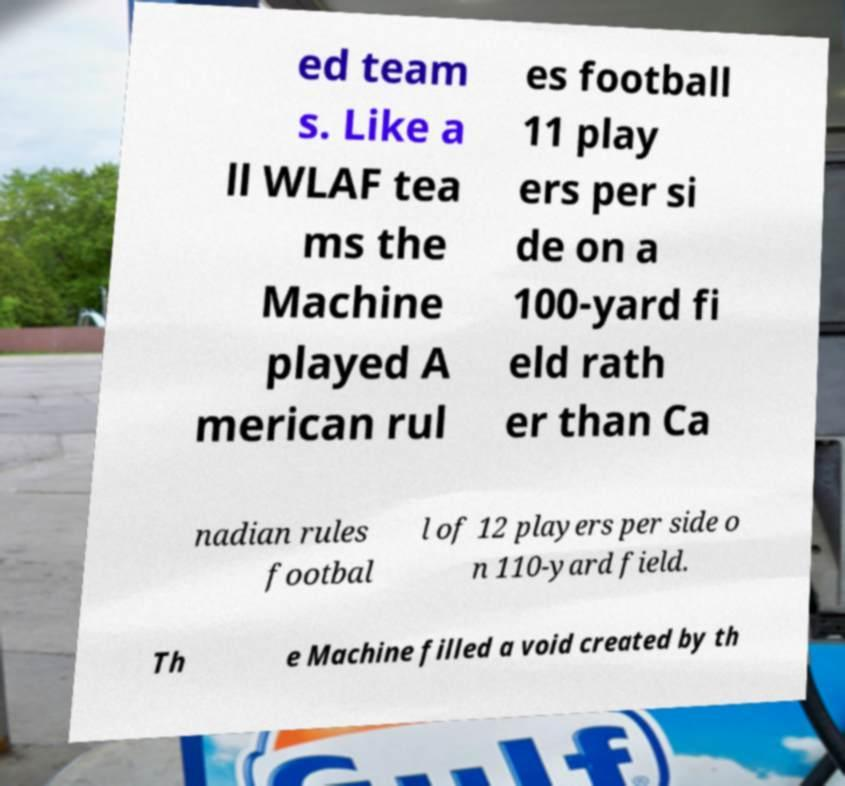Can you accurately transcribe the text from the provided image for me? ed team s. Like a ll WLAF tea ms the Machine played A merican rul es football 11 play ers per si de on a 100-yard fi eld rath er than Ca nadian rules footbal l of 12 players per side o n 110-yard field. Th e Machine filled a void created by th 